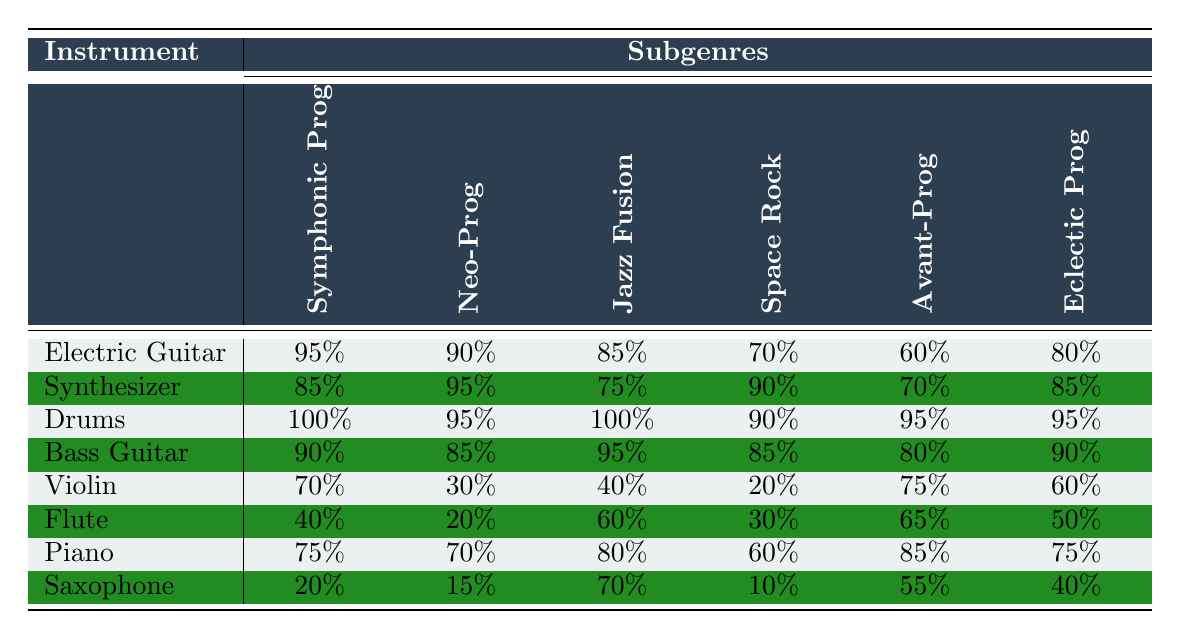What is the usage frequency of the Electric Guitar in Symphonic Prog? The table shows that the usage frequency of the Electric Guitar in the Symphonic Prog subgenre is 95%.
Answer: 95% Which instrument has the highest usage frequency in Jazz Fusion? Looking at the Jazz Fusion column, the Drums and Electric Guitar both have the highest usage frequency at 100%.
Answer: Drums and Electric Guitar What is the average usage frequency of the Synthesizer across all subgenres? To find the average, add the usage frequencies: 85 + 95 + 75 + 90 + 70 + 85 = 500. Then divide by the number of subgenres (6): 500 / 6 = 83.33.
Answer: 83.33% Does the Violin have a higher usage frequency in Space Rock compared to Avant-Prog? The usage frequency of the Violin in Space Rock is 20%, while in Avant-Prog it is 75%. Since 20% < 75%, the statement is false.
Answer: No Which instrument has the lowest overall usage frequency in Eclectic Prog? By inspecting the Eclectic Prog column, the Flute has the lowest usage frequency at 50%.
Answer: Flute What is the difference in usage frequency of Drums between Neo-Prog and Space Rock? The difference is calculated as follows: Drums in Neo-Prog is 95%, and in Space Rock it is 90%. The difference is 95% - 90% = 5%.
Answer: 5% In which subgenre is the Bass Guitar used the most? Checking the table, the highest usage frequency for the Bass Guitar is in Neo-Prog at 90%.
Answer: Neo-Prog What is the total usage frequency of the Piano across all subgenres? To calculate the total, add the usage frequencies of Piano: 75 + 70 + 80 + 60 + 85 + 75 = 445.
Answer: 445 Which instrument has consistently high usage frequencies across all subgenres? Looking at the table, the Drums have high usage frequencies, all at or greater than 90%.
Answer: Drums Is there a significant difference in the usage frequency of the Saxophone between Symphonic Prog and Space Rock? The usage frequency of the Saxophone in Symphonic Prog is 20%, and in Space Rock is 10%. The difference is 20% - 10% = 10%, which is significant considering their lower overall usage rates.
Answer: Yes 